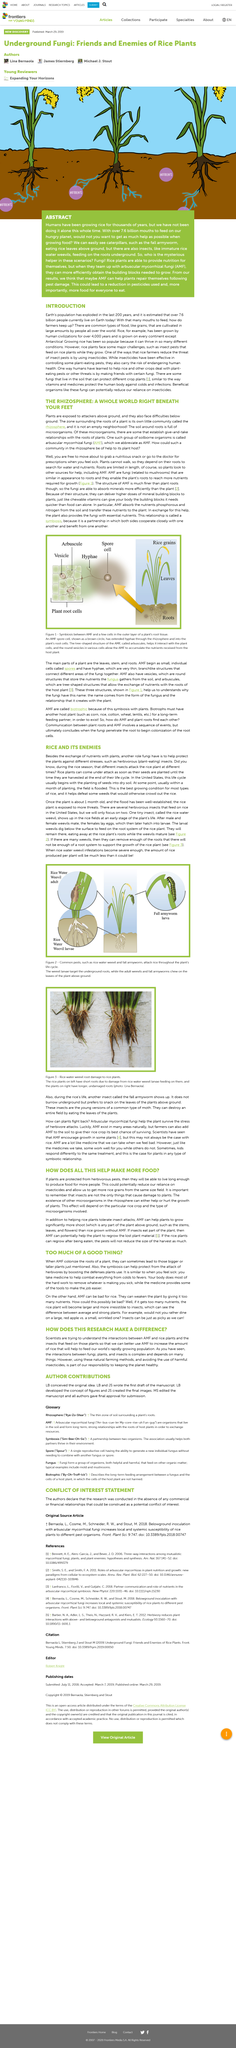Outline some significant characteristics in this image. AMF plays a beneficial role in the symbiotic relationship between plants and AMF. AMF is able to absorb minerals more efficiently and passes those nutrients onto its host plant, benefiting the growth and development of the plant. Adult fall armyworms predominantly feed on the leaves of the rice plant, targeting the above-ground growth rather than the roots. Figure 3 displays rice water weevil root damage to rice plants, revealing the extent of the pest's destructive impact on agricultural crops. Our study found that AMF transfers both phosphorous and nitrogen to plants, which are essential nutrients for their growth and development. The fall armyworm is feeding on the leaves of the plants and consuming them as snacks. 